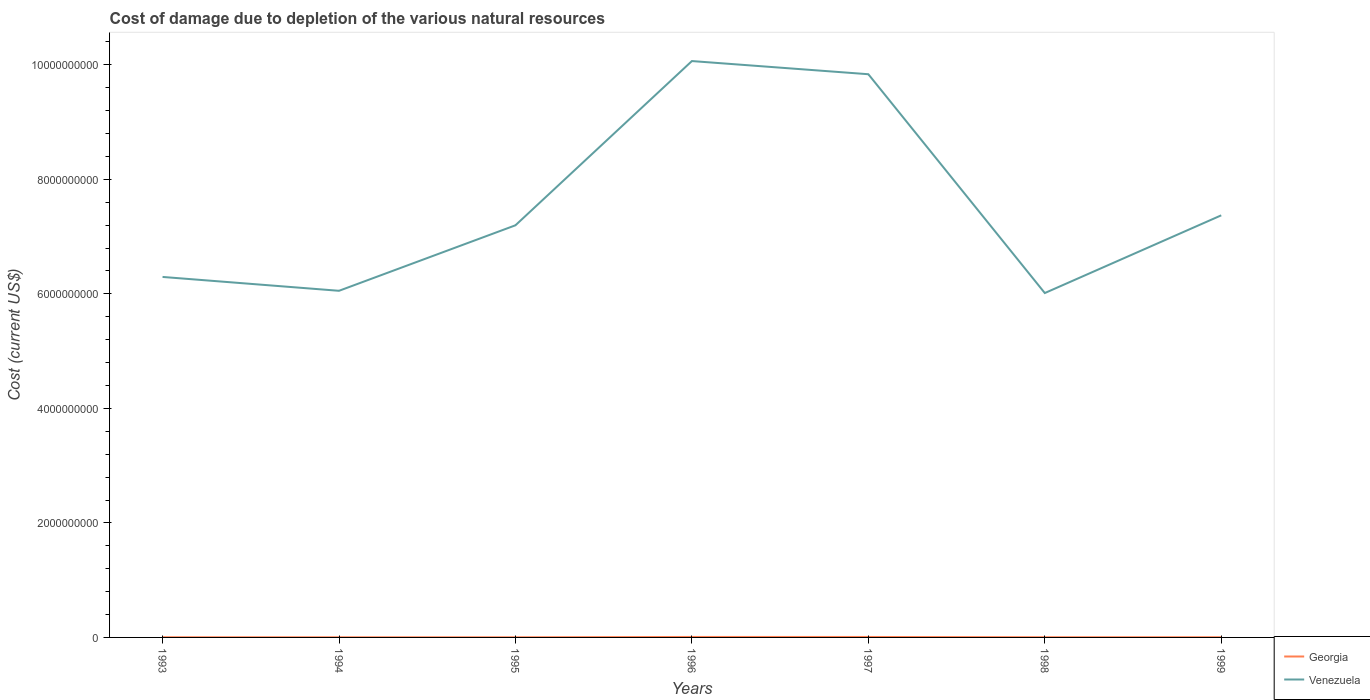Is the number of lines equal to the number of legend labels?
Ensure brevity in your answer.  Yes. Across all years, what is the maximum cost of damage caused due to the depletion of various natural resources in Georgia?
Your response must be concise. 2.45e+06. What is the total cost of damage caused due to the depletion of various natural resources in Georgia in the graph?
Your answer should be very brief. -3.32e+05. What is the difference between the highest and the second highest cost of damage caused due to the depletion of various natural resources in Georgia?
Provide a short and direct response. 5.71e+06. What is the difference between the highest and the lowest cost of damage caused due to the depletion of various natural resources in Georgia?
Make the answer very short. 2. How many lines are there?
Keep it short and to the point. 2. What is the difference between two consecutive major ticks on the Y-axis?
Your response must be concise. 2.00e+09. Are the values on the major ticks of Y-axis written in scientific E-notation?
Your answer should be very brief. No. Does the graph contain grids?
Offer a very short reply. No. Where does the legend appear in the graph?
Give a very brief answer. Bottom right. How many legend labels are there?
Provide a succinct answer. 2. How are the legend labels stacked?
Give a very brief answer. Vertical. What is the title of the graph?
Provide a succinct answer. Cost of damage due to depletion of the various natural resources. What is the label or title of the X-axis?
Keep it short and to the point. Years. What is the label or title of the Y-axis?
Provide a succinct answer. Cost (current US$). What is the Cost (current US$) of Georgia in 1993?
Your response must be concise. 3.37e+06. What is the Cost (current US$) in Venezuela in 1993?
Provide a short and direct response. 6.30e+09. What is the Cost (current US$) of Georgia in 1994?
Give a very brief answer. 2.45e+06. What is the Cost (current US$) of Venezuela in 1994?
Ensure brevity in your answer.  6.05e+09. What is the Cost (current US$) of Georgia in 1995?
Give a very brief answer. 2.56e+06. What is the Cost (current US$) in Venezuela in 1995?
Your answer should be very brief. 7.20e+09. What is the Cost (current US$) in Georgia in 1996?
Offer a very short reply. 8.16e+06. What is the Cost (current US$) in Venezuela in 1996?
Your answer should be very brief. 1.01e+1. What is the Cost (current US$) in Georgia in 1997?
Offer a terse response. 7.96e+06. What is the Cost (current US$) of Venezuela in 1997?
Give a very brief answer. 9.84e+09. What is the Cost (current US$) of Georgia in 1998?
Offer a very short reply. 3.70e+06. What is the Cost (current US$) of Venezuela in 1998?
Your answer should be very brief. 6.01e+09. What is the Cost (current US$) in Georgia in 1999?
Your response must be concise. 3.69e+06. What is the Cost (current US$) in Venezuela in 1999?
Your answer should be compact. 7.37e+09. Across all years, what is the maximum Cost (current US$) in Georgia?
Provide a succinct answer. 8.16e+06. Across all years, what is the maximum Cost (current US$) of Venezuela?
Give a very brief answer. 1.01e+1. Across all years, what is the minimum Cost (current US$) of Georgia?
Ensure brevity in your answer.  2.45e+06. Across all years, what is the minimum Cost (current US$) in Venezuela?
Keep it short and to the point. 6.01e+09. What is the total Cost (current US$) of Georgia in the graph?
Ensure brevity in your answer.  3.19e+07. What is the total Cost (current US$) of Venezuela in the graph?
Offer a terse response. 5.28e+1. What is the difference between the Cost (current US$) in Georgia in 1993 and that in 1994?
Your answer should be very brief. 9.16e+05. What is the difference between the Cost (current US$) of Venezuela in 1993 and that in 1994?
Offer a terse response. 2.42e+08. What is the difference between the Cost (current US$) of Georgia in 1993 and that in 1995?
Your response must be concise. 8.03e+05. What is the difference between the Cost (current US$) of Venezuela in 1993 and that in 1995?
Offer a terse response. -9.02e+08. What is the difference between the Cost (current US$) in Georgia in 1993 and that in 1996?
Offer a terse response. -4.79e+06. What is the difference between the Cost (current US$) in Venezuela in 1993 and that in 1996?
Ensure brevity in your answer.  -3.77e+09. What is the difference between the Cost (current US$) of Georgia in 1993 and that in 1997?
Give a very brief answer. -4.59e+06. What is the difference between the Cost (current US$) in Venezuela in 1993 and that in 1997?
Your answer should be very brief. -3.54e+09. What is the difference between the Cost (current US$) in Georgia in 1993 and that in 1998?
Make the answer very short. -3.32e+05. What is the difference between the Cost (current US$) in Venezuela in 1993 and that in 1998?
Keep it short and to the point. 2.81e+08. What is the difference between the Cost (current US$) in Georgia in 1993 and that in 1999?
Keep it short and to the point. -3.23e+05. What is the difference between the Cost (current US$) in Venezuela in 1993 and that in 1999?
Ensure brevity in your answer.  -1.08e+09. What is the difference between the Cost (current US$) of Georgia in 1994 and that in 1995?
Provide a short and direct response. -1.13e+05. What is the difference between the Cost (current US$) of Venezuela in 1994 and that in 1995?
Your response must be concise. -1.14e+09. What is the difference between the Cost (current US$) in Georgia in 1994 and that in 1996?
Keep it short and to the point. -5.71e+06. What is the difference between the Cost (current US$) of Venezuela in 1994 and that in 1996?
Your response must be concise. -4.01e+09. What is the difference between the Cost (current US$) of Georgia in 1994 and that in 1997?
Give a very brief answer. -5.51e+06. What is the difference between the Cost (current US$) of Venezuela in 1994 and that in 1997?
Keep it short and to the point. -3.78e+09. What is the difference between the Cost (current US$) in Georgia in 1994 and that in 1998?
Your answer should be compact. -1.25e+06. What is the difference between the Cost (current US$) of Venezuela in 1994 and that in 1998?
Keep it short and to the point. 3.94e+07. What is the difference between the Cost (current US$) in Georgia in 1994 and that in 1999?
Provide a succinct answer. -1.24e+06. What is the difference between the Cost (current US$) of Venezuela in 1994 and that in 1999?
Offer a terse response. -1.32e+09. What is the difference between the Cost (current US$) in Georgia in 1995 and that in 1996?
Provide a succinct answer. -5.59e+06. What is the difference between the Cost (current US$) of Venezuela in 1995 and that in 1996?
Your answer should be very brief. -2.87e+09. What is the difference between the Cost (current US$) in Georgia in 1995 and that in 1997?
Give a very brief answer. -5.39e+06. What is the difference between the Cost (current US$) of Venezuela in 1995 and that in 1997?
Ensure brevity in your answer.  -2.64e+09. What is the difference between the Cost (current US$) of Georgia in 1995 and that in 1998?
Offer a terse response. -1.14e+06. What is the difference between the Cost (current US$) in Venezuela in 1995 and that in 1998?
Keep it short and to the point. 1.18e+09. What is the difference between the Cost (current US$) in Georgia in 1995 and that in 1999?
Offer a very short reply. -1.13e+06. What is the difference between the Cost (current US$) in Venezuela in 1995 and that in 1999?
Provide a succinct answer. -1.74e+08. What is the difference between the Cost (current US$) of Georgia in 1996 and that in 1997?
Make the answer very short. 2.02e+05. What is the difference between the Cost (current US$) of Venezuela in 1996 and that in 1997?
Provide a succinct answer. 2.30e+08. What is the difference between the Cost (current US$) in Georgia in 1996 and that in 1998?
Make the answer very short. 4.46e+06. What is the difference between the Cost (current US$) in Venezuela in 1996 and that in 1998?
Offer a very short reply. 4.05e+09. What is the difference between the Cost (current US$) of Georgia in 1996 and that in 1999?
Make the answer very short. 4.47e+06. What is the difference between the Cost (current US$) in Venezuela in 1996 and that in 1999?
Offer a terse response. 2.69e+09. What is the difference between the Cost (current US$) of Georgia in 1997 and that in 1998?
Your response must be concise. 4.26e+06. What is the difference between the Cost (current US$) in Venezuela in 1997 and that in 1998?
Provide a short and direct response. 3.82e+09. What is the difference between the Cost (current US$) in Georgia in 1997 and that in 1999?
Offer a terse response. 4.27e+06. What is the difference between the Cost (current US$) of Venezuela in 1997 and that in 1999?
Your answer should be very brief. 2.46e+09. What is the difference between the Cost (current US$) in Georgia in 1998 and that in 1999?
Provide a short and direct response. 9485.98. What is the difference between the Cost (current US$) of Venezuela in 1998 and that in 1999?
Make the answer very short. -1.36e+09. What is the difference between the Cost (current US$) of Georgia in 1993 and the Cost (current US$) of Venezuela in 1994?
Provide a short and direct response. -6.05e+09. What is the difference between the Cost (current US$) of Georgia in 1993 and the Cost (current US$) of Venezuela in 1995?
Offer a very short reply. -7.19e+09. What is the difference between the Cost (current US$) of Georgia in 1993 and the Cost (current US$) of Venezuela in 1996?
Keep it short and to the point. -1.01e+1. What is the difference between the Cost (current US$) of Georgia in 1993 and the Cost (current US$) of Venezuela in 1997?
Provide a succinct answer. -9.83e+09. What is the difference between the Cost (current US$) of Georgia in 1993 and the Cost (current US$) of Venezuela in 1998?
Offer a very short reply. -6.01e+09. What is the difference between the Cost (current US$) in Georgia in 1993 and the Cost (current US$) in Venezuela in 1999?
Keep it short and to the point. -7.37e+09. What is the difference between the Cost (current US$) of Georgia in 1994 and the Cost (current US$) of Venezuela in 1995?
Provide a succinct answer. -7.20e+09. What is the difference between the Cost (current US$) in Georgia in 1994 and the Cost (current US$) in Venezuela in 1996?
Give a very brief answer. -1.01e+1. What is the difference between the Cost (current US$) in Georgia in 1994 and the Cost (current US$) in Venezuela in 1997?
Your answer should be very brief. -9.83e+09. What is the difference between the Cost (current US$) in Georgia in 1994 and the Cost (current US$) in Venezuela in 1998?
Provide a succinct answer. -6.01e+09. What is the difference between the Cost (current US$) in Georgia in 1994 and the Cost (current US$) in Venezuela in 1999?
Offer a very short reply. -7.37e+09. What is the difference between the Cost (current US$) of Georgia in 1995 and the Cost (current US$) of Venezuela in 1996?
Provide a succinct answer. -1.01e+1. What is the difference between the Cost (current US$) of Georgia in 1995 and the Cost (current US$) of Venezuela in 1997?
Keep it short and to the point. -9.83e+09. What is the difference between the Cost (current US$) in Georgia in 1995 and the Cost (current US$) in Venezuela in 1998?
Keep it short and to the point. -6.01e+09. What is the difference between the Cost (current US$) in Georgia in 1995 and the Cost (current US$) in Venezuela in 1999?
Your response must be concise. -7.37e+09. What is the difference between the Cost (current US$) in Georgia in 1996 and the Cost (current US$) in Venezuela in 1997?
Your answer should be very brief. -9.83e+09. What is the difference between the Cost (current US$) in Georgia in 1996 and the Cost (current US$) in Venezuela in 1998?
Give a very brief answer. -6.01e+09. What is the difference between the Cost (current US$) of Georgia in 1996 and the Cost (current US$) of Venezuela in 1999?
Your answer should be very brief. -7.36e+09. What is the difference between the Cost (current US$) of Georgia in 1997 and the Cost (current US$) of Venezuela in 1998?
Ensure brevity in your answer.  -6.01e+09. What is the difference between the Cost (current US$) of Georgia in 1997 and the Cost (current US$) of Venezuela in 1999?
Keep it short and to the point. -7.36e+09. What is the difference between the Cost (current US$) in Georgia in 1998 and the Cost (current US$) in Venezuela in 1999?
Your answer should be very brief. -7.37e+09. What is the average Cost (current US$) of Georgia per year?
Keep it short and to the point. 4.56e+06. What is the average Cost (current US$) in Venezuela per year?
Provide a short and direct response. 7.55e+09. In the year 1993, what is the difference between the Cost (current US$) in Georgia and Cost (current US$) in Venezuela?
Ensure brevity in your answer.  -6.29e+09. In the year 1994, what is the difference between the Cost (current US$) of Georgia and Cost (current US$) of Venezuela?
Your answer should be very brief. -6.05e+09. In the year 1995, what is the difference between the Cost (current US$) in Georgia and Cost (current US$) in Venezuela?
Make the answer very short. -7.20e+09. In the year 1996, what is the difference between the Cost (current US$) of Georgia and Cost (current US$) of Venezuela?
Your answer should be compact. -1.01e+1. In the year 1997, what is the difference between the Cost (current US$) in Georgia and Cost (current US$) in Venezuela?
Keep it short and to the point. -9.83e+09. In the year 1998, what is the difference between the Cost (current US$) of Georgia and Cost (current US$) of Venezuela?
Offer a terse response. -6.01e+09. In the year 1999, what is the difference between the Cost (current US$) in Georgia and Cost (current US$) in Venezuela?
Provide a short and direct response. -7.37e+09. What is the ratio of the Cost (current US$) in Georgia in 1993 to that in 1994?
Keep it short and to the point. 1.37. What is the ratio of the Cost (current US$) in Venezuela in 1993 to that in 1994?
Your response must be concise. 1.04. What is the ratio of the Cost (current US$) of Georgia in 1993 to that in 1995?
Your answer should be compact. 1.31. What is the ratio of the Cost (current US$) in Venezuela in 1993 to that in 1995?
Ensure brevity in your answer.  0.87. What is the ratio of the Cost (current US$) of Georgia in 1993 to that in 1996?
Provide a short and direct response. 0.41. What is the ratio of the Cost (current US$) in Venezuela in 1993 to that in 1996?
Your answer should be very brief. 0.63. What is the ratio of the Cost (current US$) of Georgia in 1993 to that in 1997?
Your answer should be very brief. 0.42. What is the ratio of the Cost (current US$) of Venezuela in 1993 to that in 1997?
Offer a terse response. 0.64. What is the ratio of the Cost (current US$) of Georgia in 1993 to that in 1998?
Provide a succinct answer. 0.91. What is the ratio of the Cost (current US$) of Venezuela in 1993 to that in 1998?
Make the answer very short. 1.05. What is the ratio of the Cost (current US$) of Georgia in 1993 to that in 1999?
Provide a succinct answer. 0.91. What is the ratio of the Cost (current US$) in Venezuela in 1993 to that in 1999?
Your answer should be very brief. 0.85. What is the ratio of the Cost (current US$) in Georgia in 1994 to that in 1995?
Your answer should be very brief. 0.96. What is the ratio of the Cost (current US$) of Venezuela in 1994 to that in 1995?
Your answer should be very brief. 0.84. What is the ratio of the Cost (current US$) in Georgia in 1994 to that in 1996?
Provide a succinct answer. 0.3. What is the ratio of the Cost (current US$) in Venezuela in 1994 to that in 1996?
Provide a short and direct response. 0.6. What is the ratio of the Cost (current US$) of Georgia in 1994 to that in 1997?
Offer a terse response. 0.31. What is the ratio of the Cost (current US$) of Venezuela in 1994 to that in 1997?
Give a very brief answer. 0.62. What is the ratio of the Cost (current US$) of Georgia in 1994 to that in 1998?
Keep it short and to the point. 0.66. What is the ratio of the Cost (current US$) of Georgia in 1994 to that in 1999?
Give a very brief answer. 0.66. What is the ratio of the Cost (current US$) in Venezuela in 1994 to that in 1999?
Offer a very short reply. 0.82. What is the ratio of the Cost (current US$) of Georgia in 1995 to that in 1996?
Your answer should be very brief. 0.31. What is the ratio of the Cost (current US$) in Venezuela in 1995 to that in 1996?
Provide a short and direct response. 0.71. What is the ratio of the Cost (current US$) of Georgia in 1995 to that in 1997?
Provide a short and direct response. 0.32. What is the ratio of the Cost (current US$) of Venezuela in 1995 to that in 1997?
Make the answer very short. 0.73. What is the ratio of the Cost (current US$) of Georgia in 1995 to that in 1998?
Make the answer very short. 0.69. What is the ratio of the Cost (current US$) of Venezuela in 1995 to that in 1998?
Provide a short and direct response. 1.2. What is the ratio of the Cost (current US$) in Georgia in 1995 to that in 1999?
Your answer should be very brief. 0.69. What is the ratio of the Cost (current US$) in Venezuela in 1995 to that in 1999?
Offer a terse response. 0.98. What is the ratio of the Cost (current US$) in Georgia in 1996 to that in 1997?
Provide a succinct answer. 1.03. What is the ratio of the Cost (current US$) in Venezuela in 1996 to that in 1997?
Your response must be concise. 1.02. What is the ratio of the Cost (current US$) of Georgia in 1996 to that in 1998?
Make the answer very short. 2.21. What is the ratio of the Cost (current US$) of Venezuela in 1996 to that in 1998?
Keep it short and to the point. 1.67. What is the ratio of the Cost (current US$) in Georgia in 1996 to that in 1999?
Keep it short and to the point. 2.21. What is the ratio of the Cost (current US$) in Venezuela in 1996 to that in 1999?
Provide a succinct answer. 1.37. What is the ratio of the Cost (current US$) in Georgia in 1997 to that in 1998?
Provide a short and direct response. 2.15. What is the ratio of the Cost (current US$) of Venezuela in 1997 to that in 1998?
Offer a very short reply. 1.64. What is the ratio of the Cost (current US$) in Georgia in 1997 to that in 1999?
Your response must be concise. 2.16. What is the ratio of the Cost (current US$) in Venezuela in 1997 to that in 1999?
Keep it short and to the point. 1.33. What is the ratio of the Cost (current US$) in Georgia in 1998 to that in 1999?
Offer a very short reply. 1. What is the ratio of the Cost (current US$) in Venezuela in 1998 to that in 1999?
Your answer should be compact. 0.82. What is the difference between the highest and the second highest Cost (current US$) in Georgia?
Provide a succinct answer. 2.02e+05. What is the difference between the highest and the second highest Cost (current US$) of Venezuela?
Offer a very short reply. 2.30e+08. What is the difference between the highest and the lowest Cost (current US$) in Georgia?
Your answer should be very brief. 5.71e+06. What is the difference between the highest and the lowest Cost (current US$) in Venezuela?
Your answer should be very brief. 4.05e+09. 